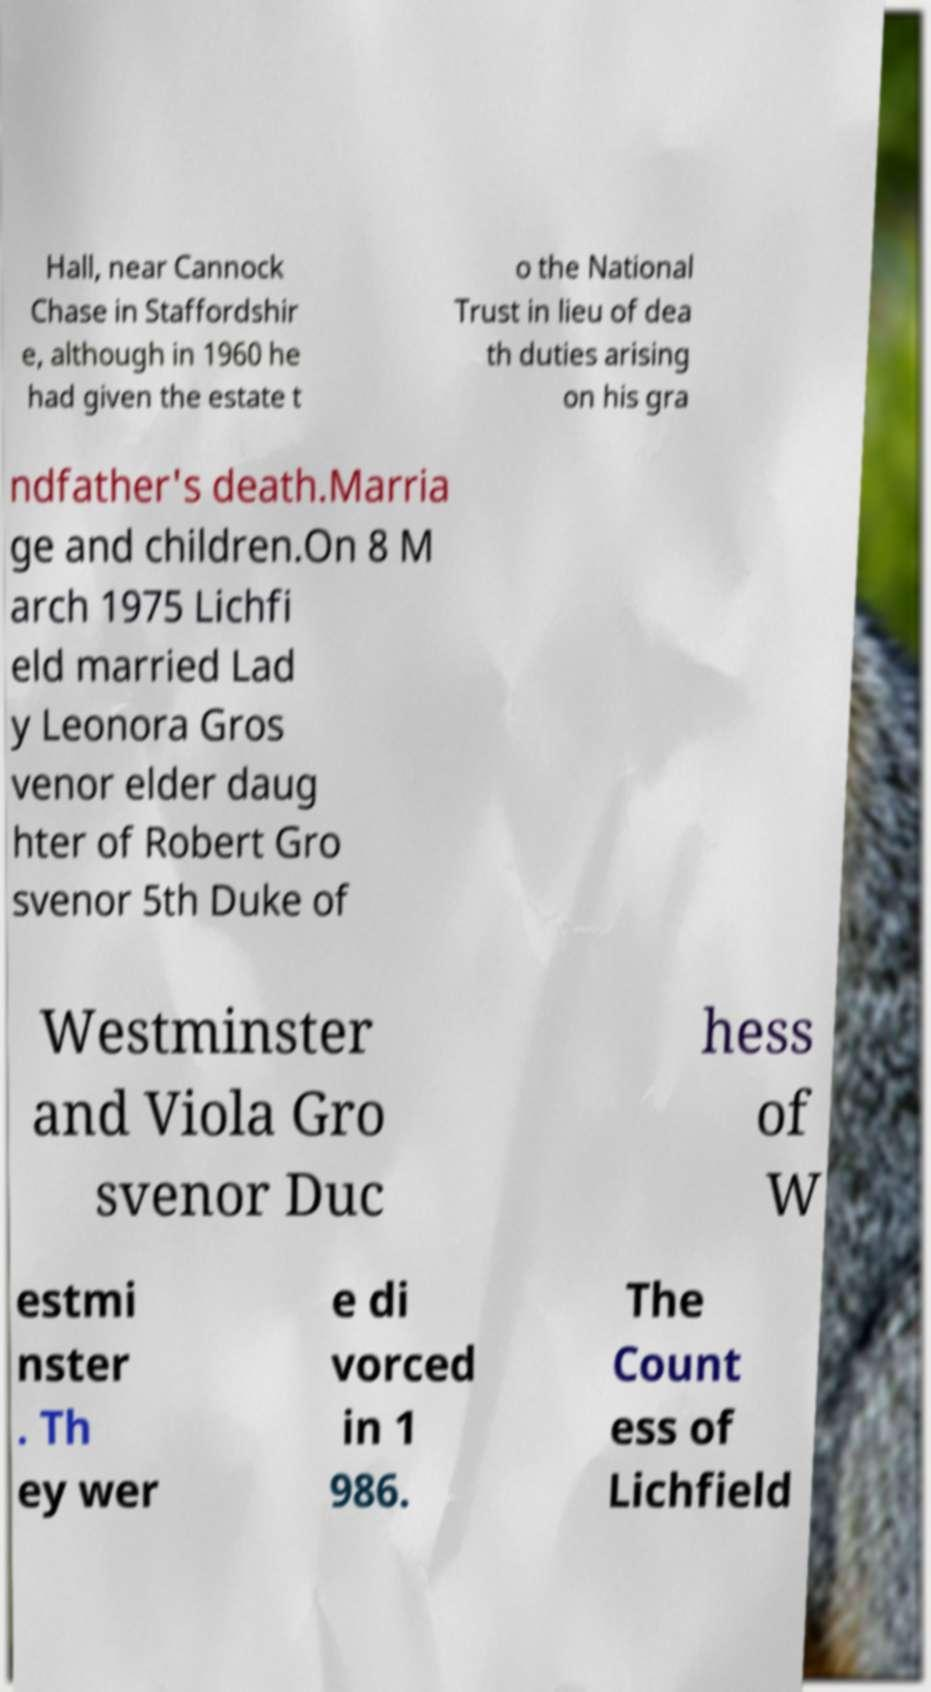Please identify and transcribe the text found in this image. Hall, near Cannock Chase in Staffordshir e, although in 1960 he had given the estate t o the National Trust in lieu of dea th duties arising on his gra ndfather's death.Marria ge and children.On 8 M arch 1975 Lichfi eld married Lad y Leonora Gros venor elder daug hter of Robert Gro svenor 5th Duke of Westminster and Viola Gro svenor Duc hess of W estmi nster . Th ey wer e di vorced in 1 986. The Count ess of Lichfield 